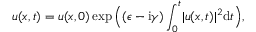<formula> <loc_0><loc_0><loc_500><loc_500>u ( x , t ) = u ( x , 0 ) \exp \left ( ( \epsilon - i \gamma ) \int _ { 0 } ^ { t } | u ( x , t ) | ^ { 2 } d t \right ) ,</formula> 